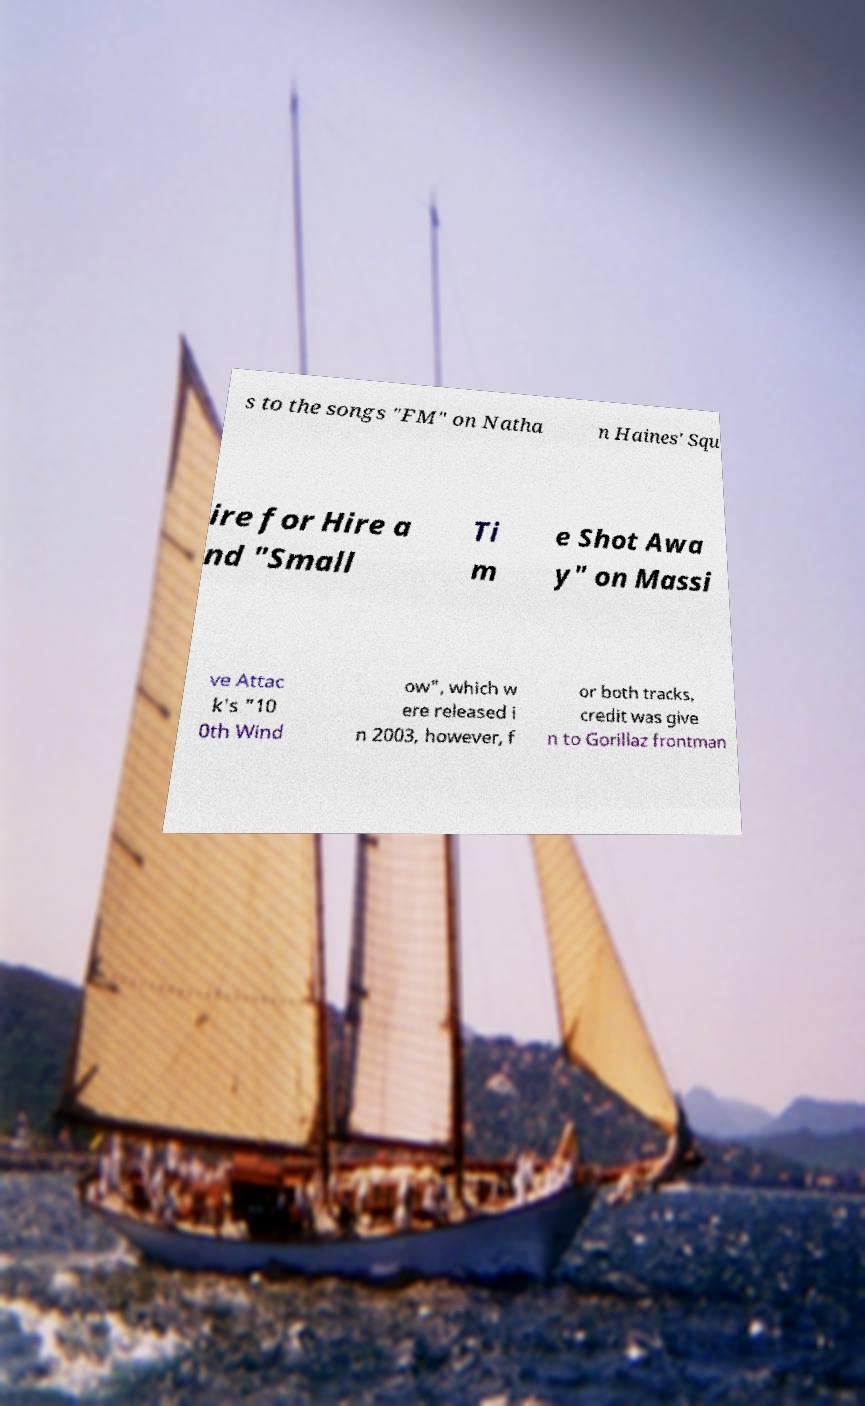Can you accurately transcribe the text from the provided image for me? s to the songs "FM" on Natha n Haines' Squ ire for Hire a nd "Small Ti m e Shot Awa y" on Massi ve Attac k's "10 0th Wind ow", which w ere released i n 2003, however, f or both tracks, credit was give n to Gorillaz frontman 